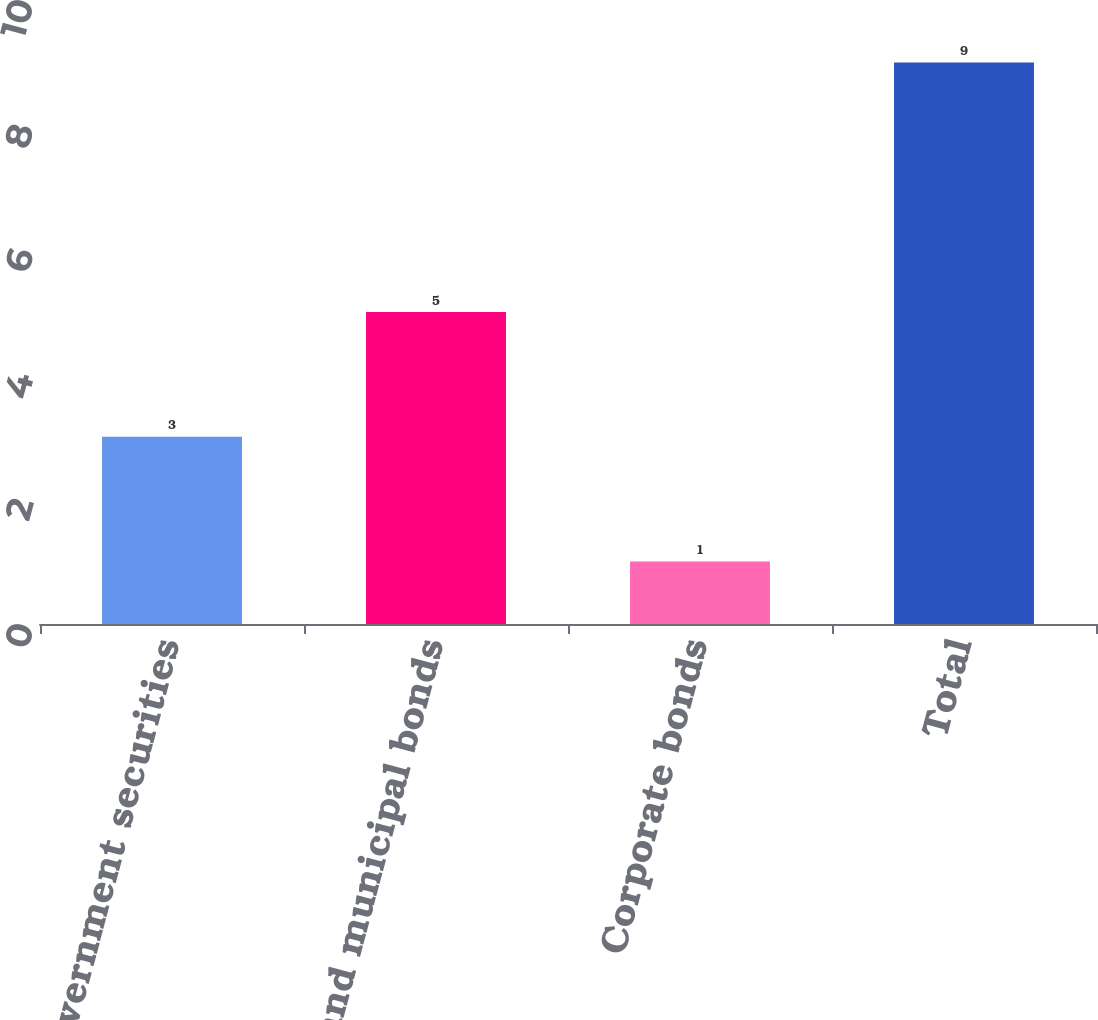<chart> <loc_0><loc_0><loc_500><loc_500><bar_chart><fcel>Government securities<fcel>State and municipal bonds<fcel>Corporate bonds<fcel>Total<nl><fcel>3<fcel>5<fcel>1<fcel>9<nl></chart> 